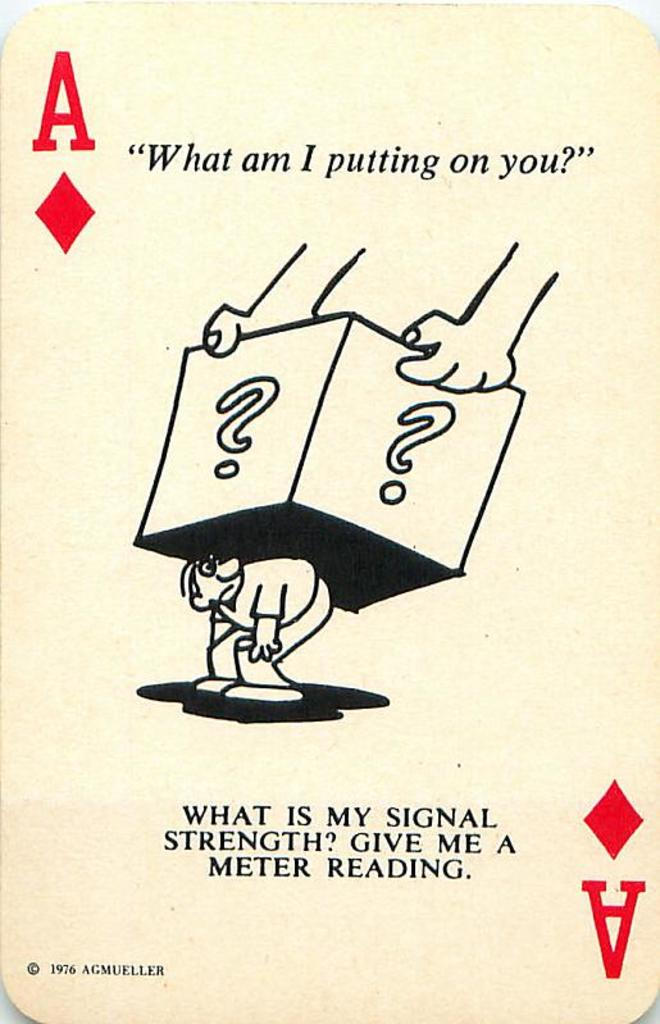What might the year 1976 on the card indicate about the era of its creation, in relation to its design and message? The year 1976 places the card in the mid-1970s, a period marked by significant social and economic changes globally. This era saw heightened awareness of personal and societal stresses, alongside advancements in communication technologies and shifts in social dynamics. The card's design and messages could be reflecting on these themes, using the visual metaphor of burden and the queries about 'signal strength' to comment on the individual's capacity to adapt and communicate effectively during such transformative times. 